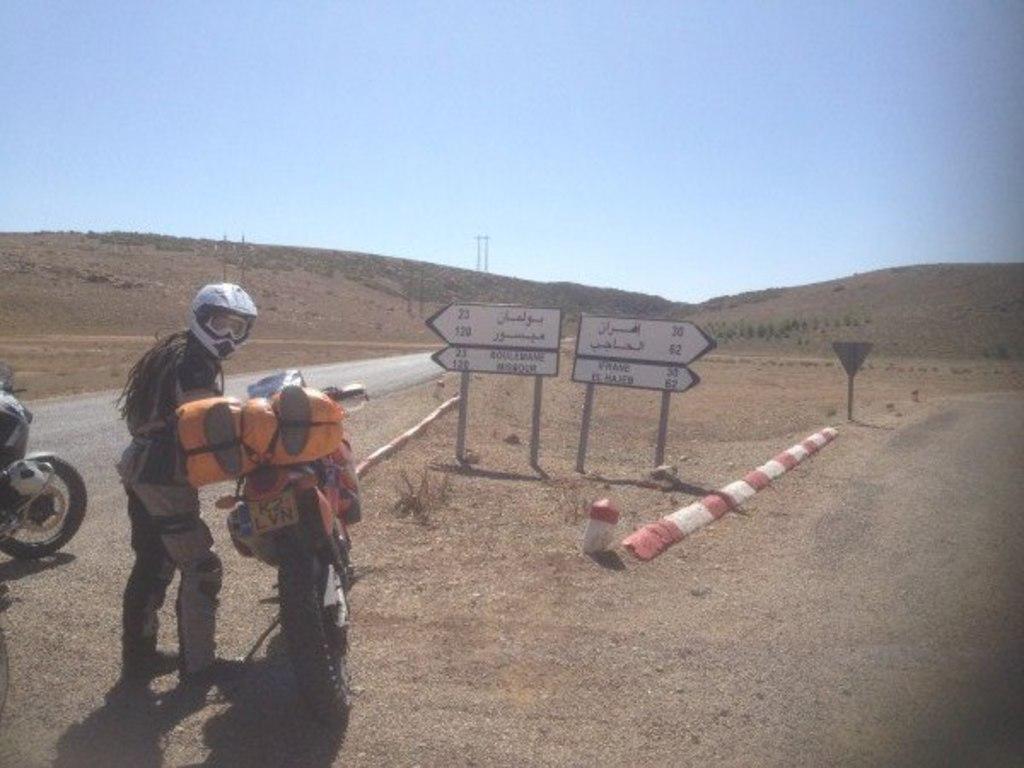Describe this image in one or two sentences. In this image I can see a person wearing dress is standing and holding a motor bike. On the motorbike I can see an orange colored bag. In the background I can see the road, few boards, few mountains, another motorbike and the sky. 